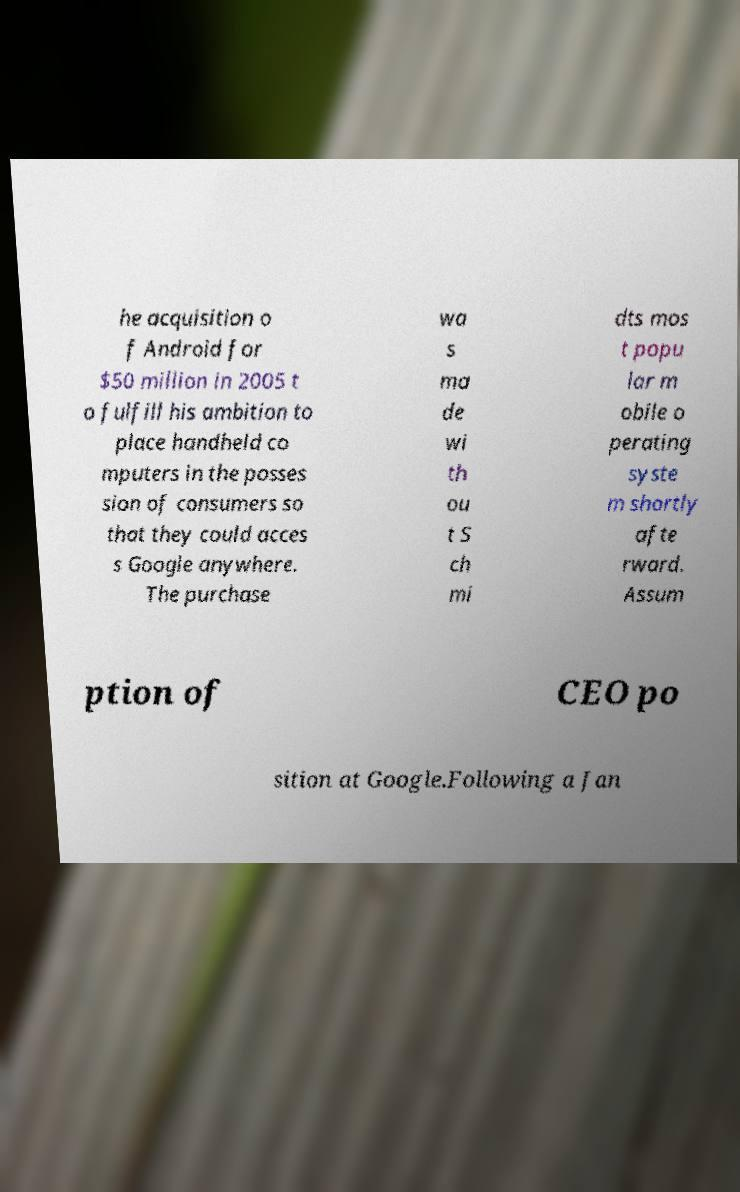Can you accurately transcribe the text from the provided image for me? he acquisition o f Android for $50 million in 2005 t o fulfill his ambition to place handheld co mputers in the posses sion of consumers so that they could acces s Google anywhere. The purchase wa s ma de wi th ou t S ch mi dts mos t popu lar m obile o perating syste m shortly afte rward. Assum ption of CEO po sition at Google.Following a Jan 